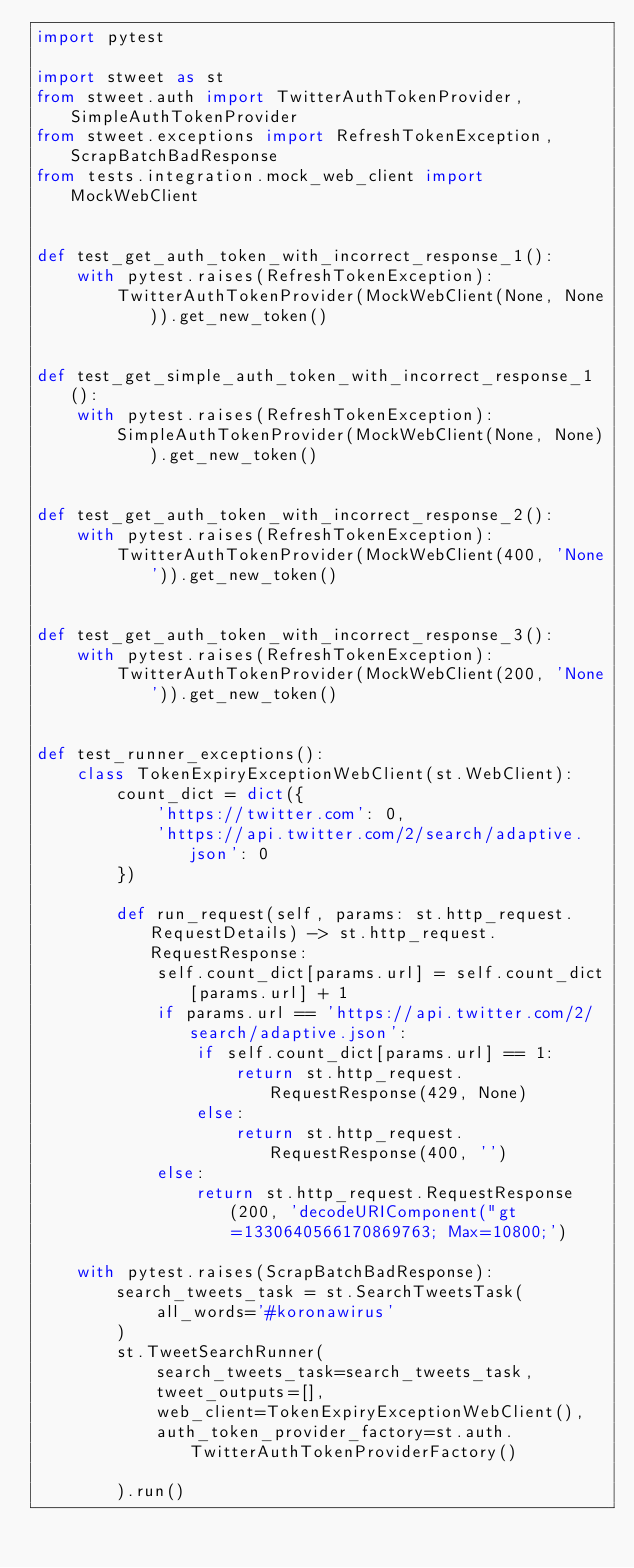Convert code to text. <code><loc_0><loc_0><loc_500><loc_500><_Python_>import pytest

import stweet as st
from stweet.auth import TwitterAuthTokenProvider, SimpleAuthTokenProvider
from stweet.exceptions import RefreshTokenException, ScrapBatchBadResponse
from tests.integration.mock_web_client import MockWebClient


def test_get_auth_token_with_incorrect_response_1():
    with pytest.raises(RefreshTokenException):
        TwitterAuthTokenProvider(MockWebClient(None, None)).get_new_token()


def test_get_simple_auth_token_with_incorrect_response_1():
    with pytest.raises(RefreshTokenException):
        SimpleAuthTokenProvider(MockWebClient(None, None)).get_new_token()


def test_get_auth_token_with_incorrect_response_2():
    with pytest.raises(RefreshTokenException):
        TwitterAuthTokenProvider(MockWebClient(400, 'None')).get_new_token()


def test_get_auth_token_with_incorrect_response_3():
    with pytest.raises(RefreshTokenException):
        TwitterAuthTokenProvider(MockWebClient(200, 'None')).get_new_token()


def test_runner_exceptions():
    class TokenExpiryExceptionWebClient(st.WebClient):
        count_dict = dict({
            'https://twitter.com': 0,
            'https://api.twitter.com/2/search/adaptive.json': 0
        })

        def run_request(self, params: st.http_request.RequestDetails) -> st.http_request.RequestResponse:
            self.count_dict[params.url] = self.count_dict[params.url] + 1
            if params.url == 'https://api.twitter.com/2/search/adaptive.json':
                if self.count_dict[params.url] == 1:
                    return st.http_request.RequestResponse(429, None)
                else:
                    return st.http_request.RequestResponse(400, '')
            else:
                return st.http_request.RequestResponse(200, 'decodeURIComponent("gt=1330640566170869763; Max=10800;')

    with pytest.raises(ScrapBatchBadResponse):
        search_tweets_task = st.SearchTweetsTask(
            all_words='#koronawirus'
        )
        st.TweetSearchRunner(
            search_tweets_task=search_tweets_task,
            tweet_outputs=[],
            web_client=TokenExpiryExceptionWebClient(),
            auth_token_provider_factory=st.auth.TwitterAuthTokenProviderFactory()

        ).run()
</code> 